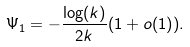<formula> <loc_0><loc_0><loc_500><loc_500>\Psi _ { 1 } = - \frac { \log ( k ) } { 2 k } ( 1 + o ( 1 ) ) .</formula> 